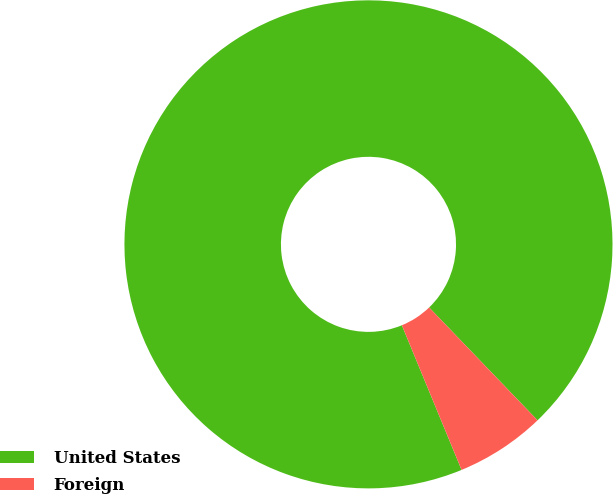Convert chart. <chart><loc_0><loc_0><loc_500><loc_500><pie_chart><fcel>United States<fcel>Foreign<nl><fcel>94.05%<fcel>5.95%<nl></chart> 